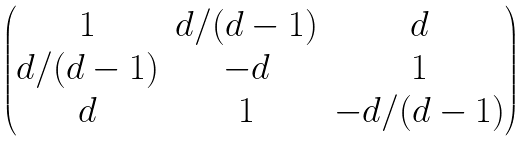<formula> <loc_0><loc_0><loc_500><loc_500>\begin{pmatrix} 1 & d / ( d - 1 ) & d \\ d / ( d - 1 ) & - d & 1 \\ d & 1 & - d / ( d - 1 ) \end{pmatrix}</formula> 